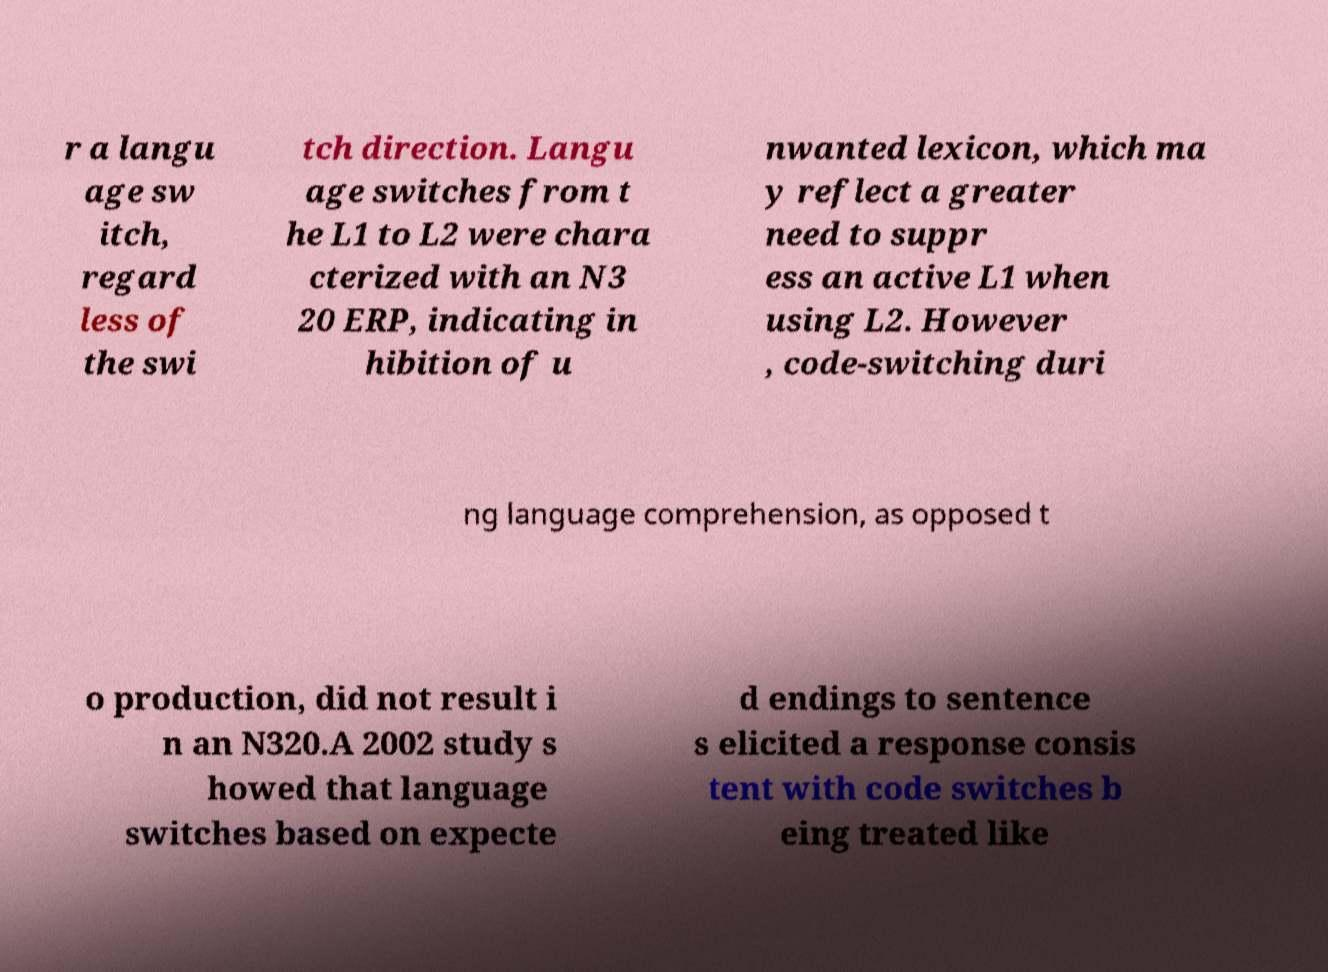Can you read and provide the text displayed in the image?This photo seems to have some interesting text. Can you extract and type it out for me? r a langu age sw itch, regard less of the swi tch direction. Langu age switches from t he L1 to L2 were chara cterized with an N3 20 ERP, indicating in hibition of u nwanted lexicon, which ma y reflect a greater need to suppr ess an active L1 when using L2. However , code-switching duri ng language comprehension, as opposed t o production, did not result i n an N320.A 2002 study s howed that language switches based on expecte d endings to sentence s elicited a response consis tent with code switches b eing treated like 